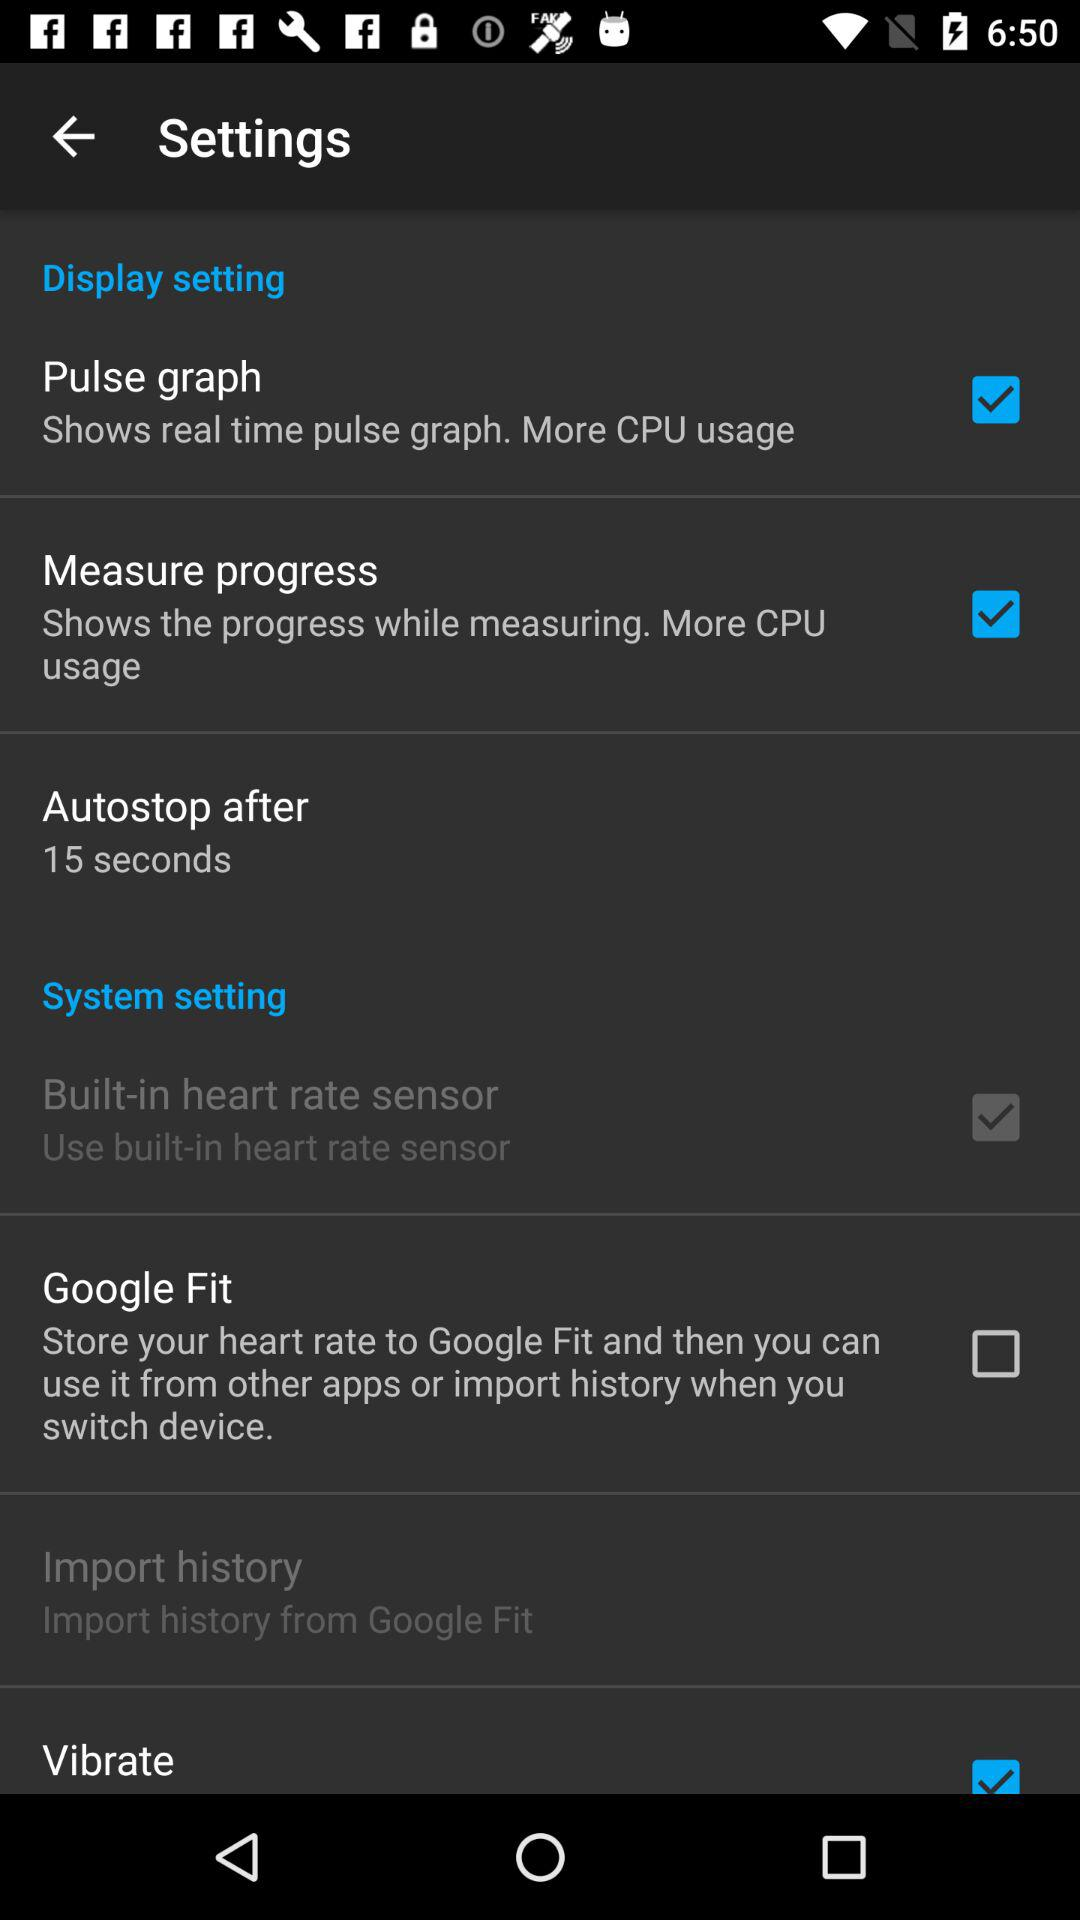After how many seconds does the autostop occur? The autostop occur after 15 seconds. 